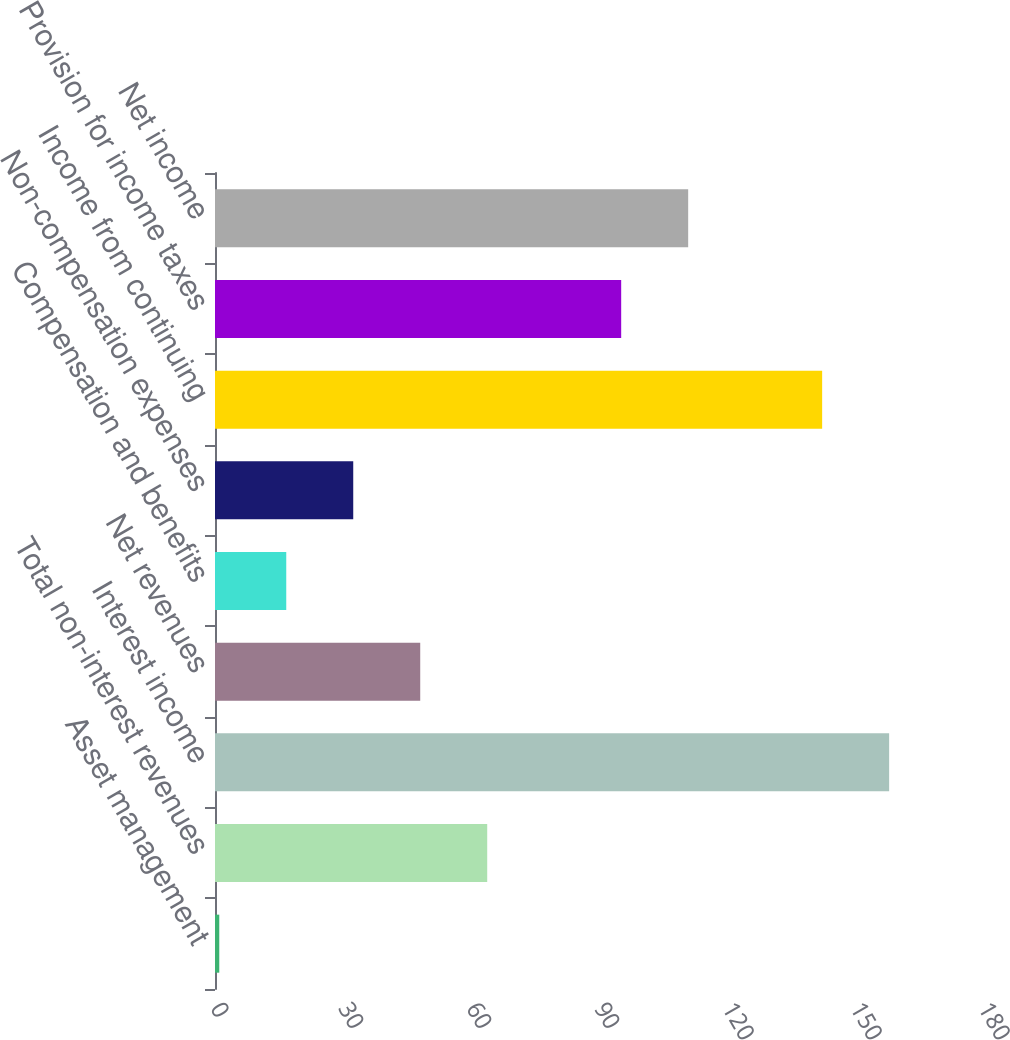Convert chart. <chart><loc_0><loc_0><loc_500><loc_500><bar_chart><fcel>Asset management<fcel>Total non-interest revenues<fcel>Interest income<fcel>Net revenues<fcel>Compensation and benefits<fcel>Non-compensation expenses<fcel>Income from continuing<fcel>Provision for income taxes<fcel>Net income<nl><fcel>1<fcel>63.8<fcel>158<fcel>48.1<fcel>16.7<fcel>32.4<fcel>142.3<fcel>95.2<fcel>110.9<nl></chart> 